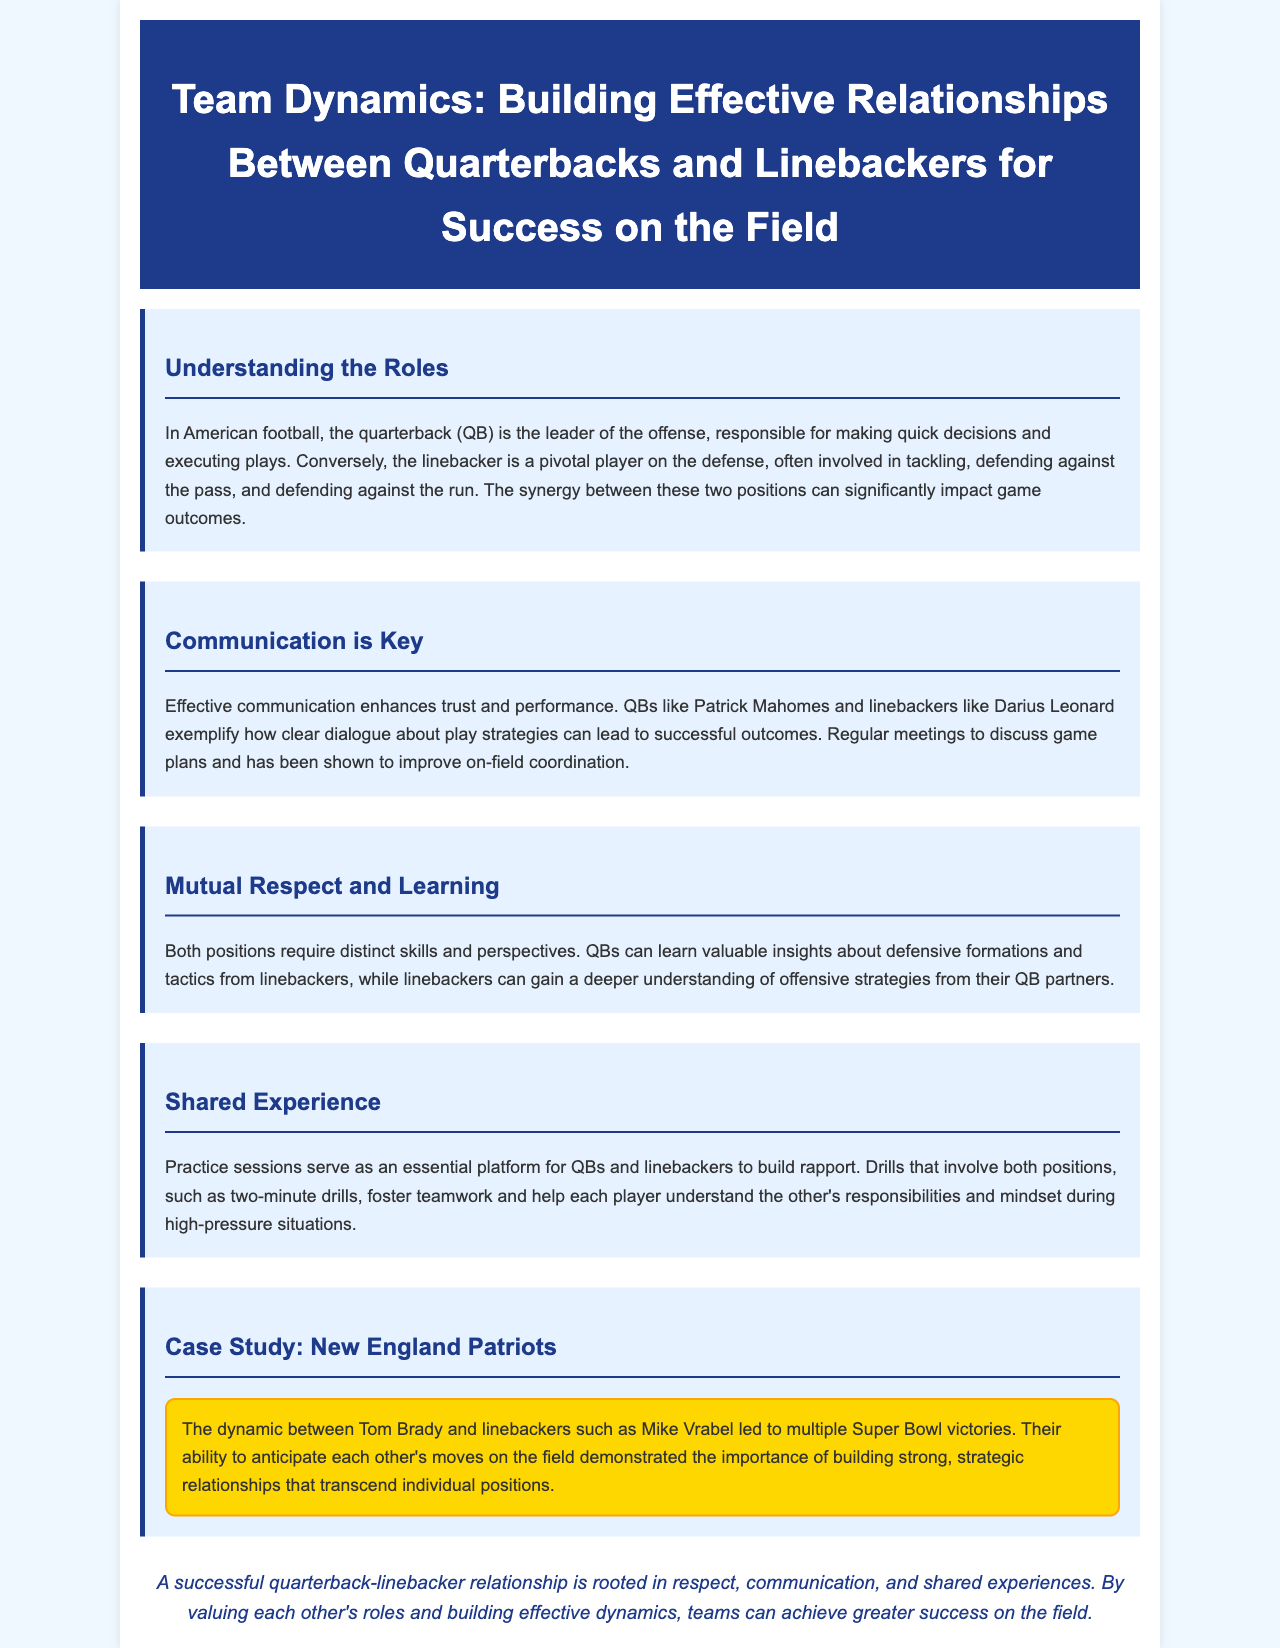What is the role of a quarterback? The quarterback (QB) is the leader of the offense, responsible for making quick decisions and executing plays.
Answer: leader of the offense Who are the two players highlighted as examples of effective communication? The document mentions quarterbacks like Patrick Mahomes and linebackers like Darius Leonard as examples.
Answer: Patrick Mahomes and Darius Leonard What is crucial for enhancing trust and performance on the field? Effective communication enhances trust and performance.
Answer: Effective communication What do practice sessions primarily serve as? Practice sessions serve as an essential platform for QBs and linebackers to build rapport.
Answer: essential platform for building rapport Which team is used as a case study in the document? The dynamic between Tom Brady and Mike Vrabel is discussed in the context of Super Bowl victories.
Answer: New England Patriots What is a benefit of shared experiences during practice? Shared experiences help each player understand the other's responsibilities and mindset.
Answer: understand each other's responsibilities What color is used for the section headers? The section headers are colored with a specific shade of blue.
Answer: blue What can QBs learn from linebackers? QBs can learn valuable insights about defensive formations and tactics from linebackers.
Answer: insights about defensive formations What is emphasized as a foundation for a successful relationship between QBs and linebackers? Respect, communication, and shared experiences are emphasized as foundations.
Answer: respect, communication, and shared experiences 